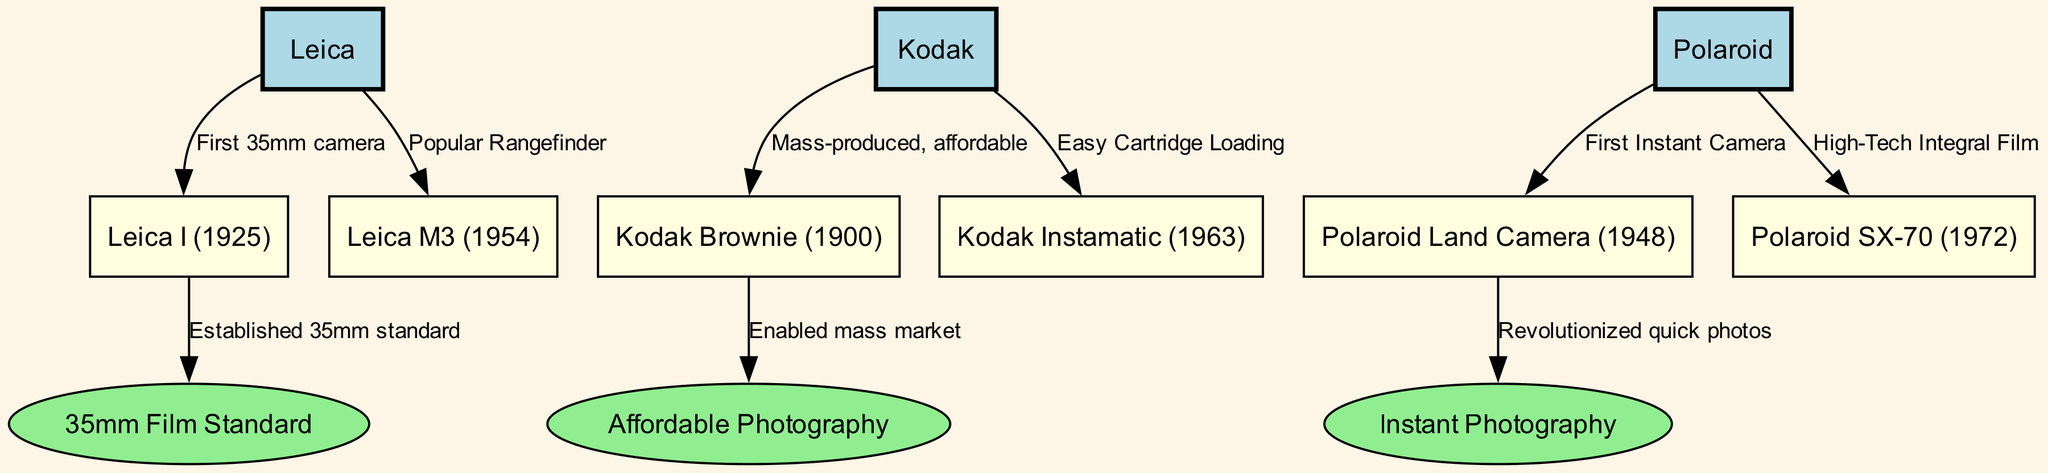What is the iconic model of Leica introduced in 1925? The diagram specifies that the Leica I was introduced in 1925 as identified in node 4, which is connected to Leica (node 1).
Answer: Leica I (1925) Which camera model is known for enabling mass market photography? The Kodak Brownie, indicated in node 6, is connected to the contribution of enabling mass market photography (node 11), showing its significant impact.
Answer: Kodak Brownie (1900) How many camera models are mentioned in the diagram? The nodes 4, 5, 6, 7, 8, and 9 represent camera models, totaling 6 models, which can be counted directly from the diagram.
Answer: 6 What type of photography was revolutionized by the Polaroid Land Camera? The diagram indicates that the Polaroid Land Camera is linked to the revolution of quick photos (node 12), implying its contribution to this specific photography type.
Answer: Instant Photography Which camera is known as the first 35mm camera? According to the diagram, the first 35mm camera is labeled as the Leica I (node 4), which shows its pioneering role in the history of cameras.
Answer: Leica I (1925) What feature did the Kodak Instamatic introduce in 1963? The diagram connects Kodak Instamatic (node 7) with the feature of easy cartridge loading, indicating its innovation in user-friendliness.
Answer: Easy Cartridge Loading What is the relationship between the Leica M3 and the popular rangefinder? The diagram describes the Leica M3 (node 5) as a "Popular Rangefinder," which elaborates on its significance in photographic equipment.
Answer: Popular Rangefinder Which model represents the first instant camera? The diagram connects the Polaroid Land Camera (node 8) with the title of the first instant camera, establishing its historical importance.
Answer: Polaroid Land Camera (1948) 